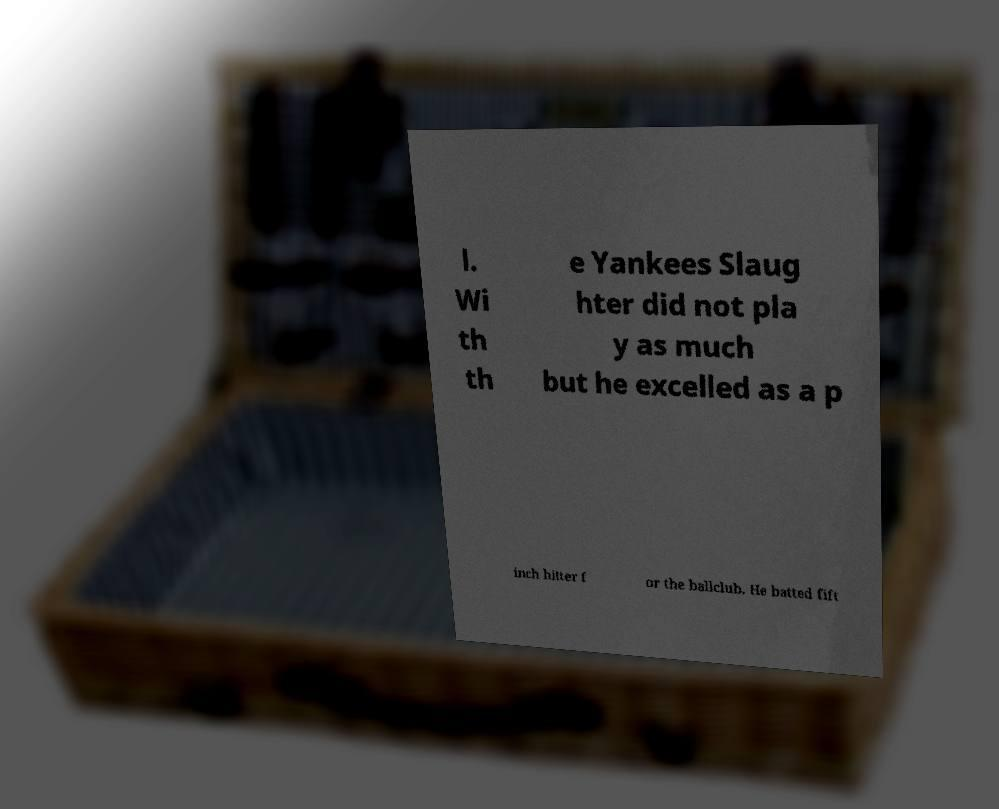For documentation purposes, I need the text within this image transcribed. Could you provide that? l. Wi th th e Yankees Slaug hter did not pla y as much but he excelled as a p inch hitter f or the ballclub. He batted fift 